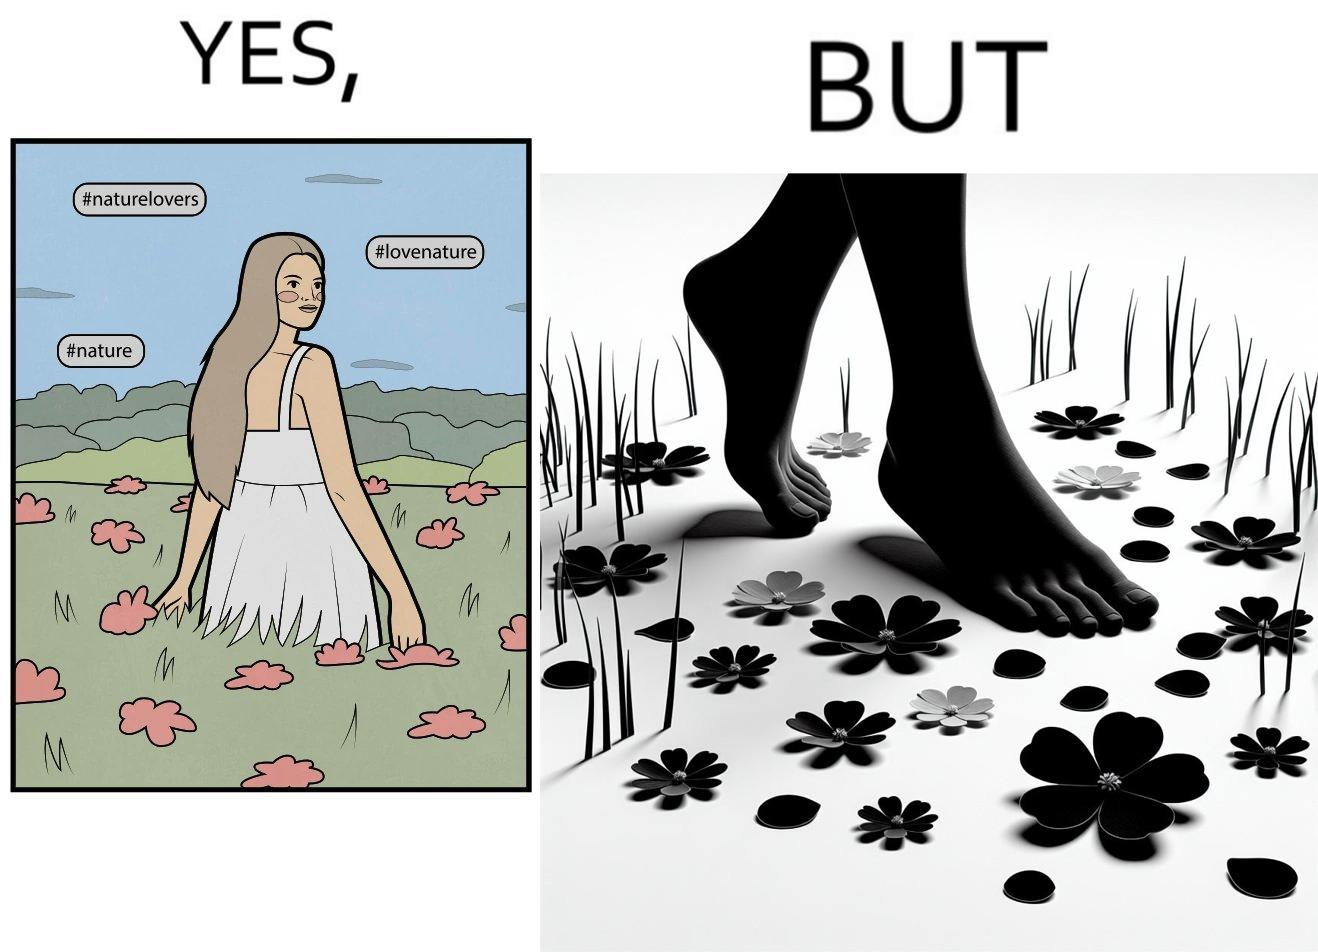What is the satirical meaning behind this image? The image is ironical, as the social ,edia post shows the appreciation of nature, while an image of the feet on the ground stepping on the flower petals shows an unintentional disrespect of nature. 